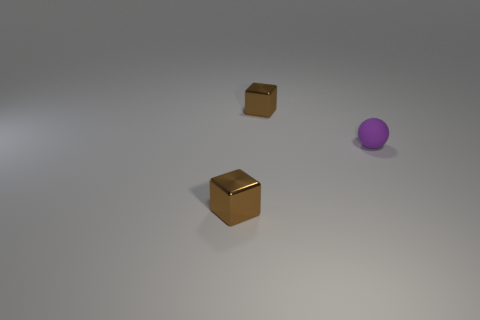Can you describe the lighting and shadows in the image? The lighting in the image comes from above, casting soft-edged shadows directly underneath the objects. The diffuse light minimizes harsh reflections and creates a gentle gradient across the surface, suggesting an interior setting with possibly a single light source. 